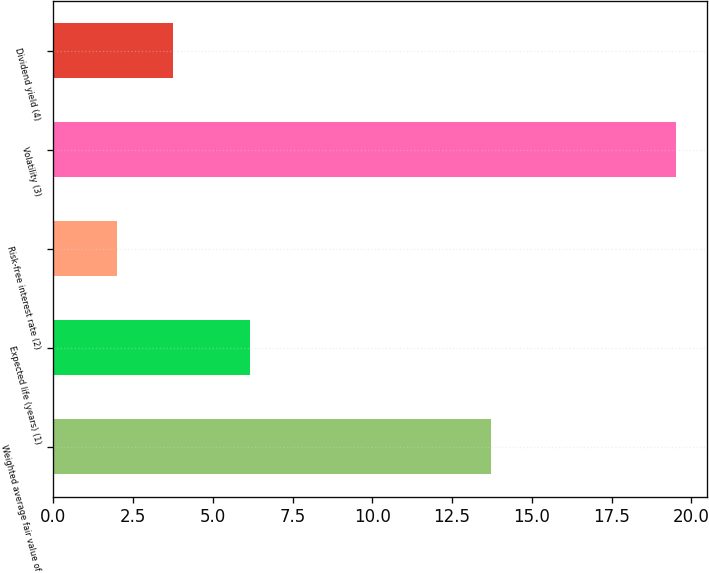<chart> <loc_0><loc_0><loc_500><loc_500><bar_chart><fcel>Weighted average fair value of<fcel>Expected life (years) (1)<fcel>Risk-free interest rate (2)<fcel>Volatility (3)<fcel>Dividend yield (4)<nl><fcel>13.71<fcel>6.16<fcel>2<fcel>19.51<fcel>3.75<nl></chart> 